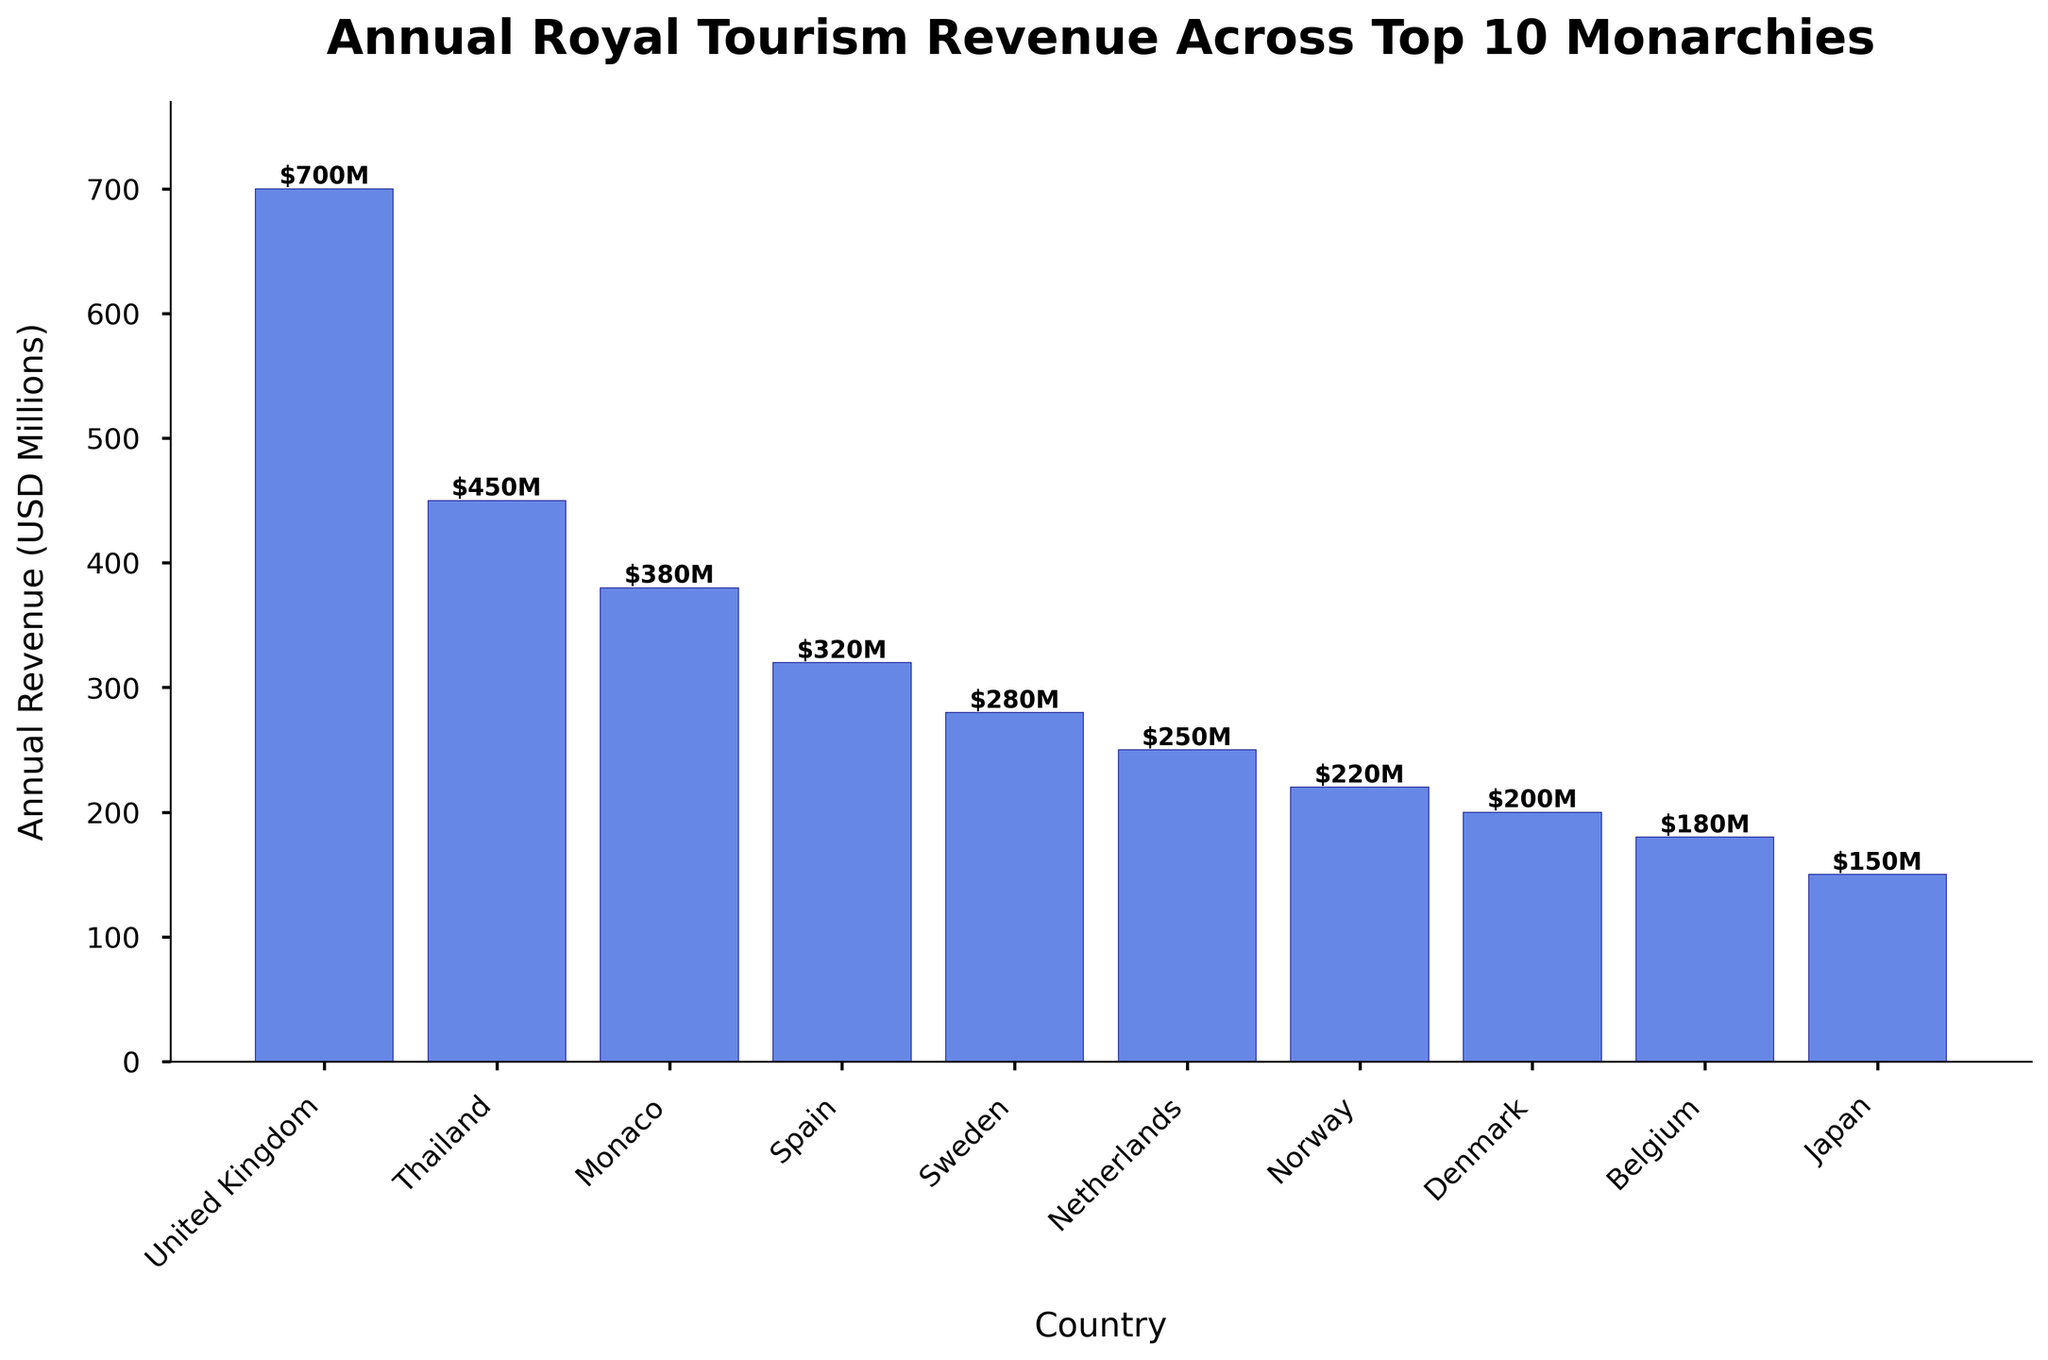Which country has the highest annual royal tourism revenue? The chart shows bars representing the royal tourism revenue for each country. The tallest bar belongs to the United Kingdom, indicating the highest revenue.
Answer: United Kingdom Which country has the lowest annual royal tourism revenue? The chart displays the bar heights for each country. The shortest bar corresponds to Japan, indicating the lowest annual revenue.
Answer: Japan How much more annual revenue does the United Kingdom generate compared to Spain? Find the bar heights for both the United Kingdom and Spain. The United Kingdom generates $700 million and Spain generates $320 million. Subtracting these values, $700M - $320M = $380M.
Answer: $380 million What is the combined annual revenue of Monaco and Thailand? Find the bar heights for both Monaco and Thailand. Monaco generates $380M and Thailand generates $450M. Adding these values, $380M + $450M = $830M.
Answer: $830 million Which three countries have annual revenues closest to $300 million? Look at the bars near the $300 million mark. Spain ($320M), Sweden ($280M), and the Netherlands ($250M) are the three countries with revenues closest to $300 million.
Answer: Spain, Sweden, Netherlands What is the average annual royal tourism revenue for all countries shown in the chart? Add up the revenues of all countries and divide by the number of countries. ($700M + $450M + $380M + $320M + $280M + $250M + $220M + $200M + $180M + $150M) / 10 = $3130M / 10 = $313M
Answer: $313 million How much annual revenue do the Scandinavian countries (Sweden, Norway, and Denmark) generate in total? Find the bar heights for Sweden, Norway, and Denmark. Sweden generates $280M, Norway $220M, and Denmark $200M. Adding these values, $280M + $220M + $200M = $700M.
Answer: $700 million Which country generates more royal tourism revenue: Belgium or Japan? Compare the bar heights for Belgium and Japan. Belgium generates $180M while Japan generates $150M. Belgium generates more revenue.
Answer: Belgium Are there more countries with annual royal tourism revenue above $300 million or below $300 million? Count the number of bars above and below the $300 million mark. Above: United Kingdom, Thailand, and Monaco (3 countries). Below: Spain (just above the $300M mark), Sweden, Netherlands, Norway, Denmark, Belgium, Japan (7 countries). There are more countries below $300 million.
Answer: Below What percentage of the total annual revenue does Thailand's revenue represent? Calculate the total revenue of all countries: $3130M. Thailand's revenue is $450M. The percentage is $(450/3130) * 100% ≈ 14.37%.
Answer: 14.37% 